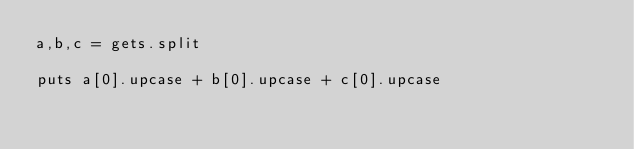Convert code to text. <code><loc_0><loc_0><loc_500><loc_500><_Ruby_>a,b,c = gets.split

puts a[0].upcase + b[0].upcase + c[0].upcase
</code> 